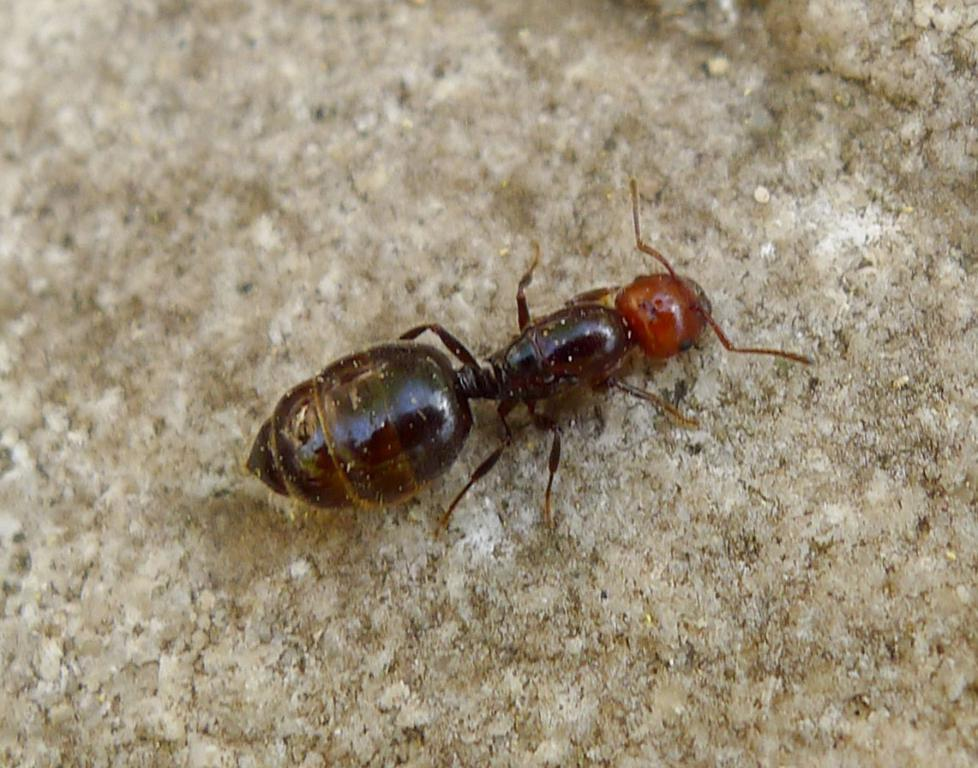What type of creature can be seen in the image? There is an insect in the image. Where is the insect located in the image? The insect is on a surface. What type of grain is being processed by the insect in the image? There is no grain present in the image, and the insect is not shown processing any grain. 